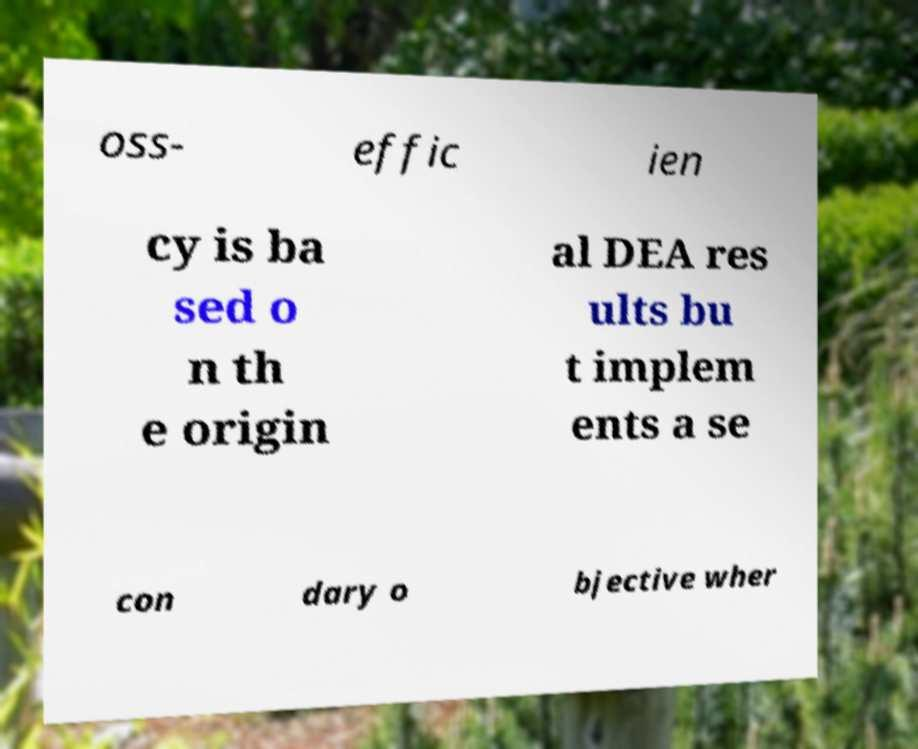Could you extract and type out the text from this image? oss- effic ien cy is ba sed o n th e origin al DEA res ults bu t implem ents a se con dary o bjective wher 